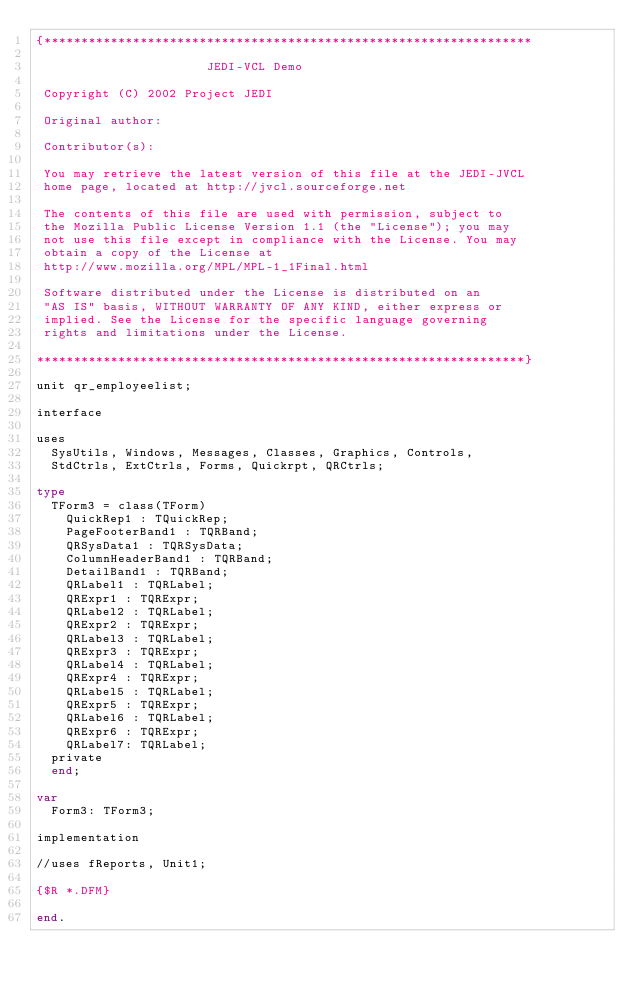Convert code to text. <code><loc_0><loc_0><loc_500><loc_500><_Pascal_>{******************************************************************

                       JEDI-VCL Demo

 Copyright (C) 2002 Project JEDI

 Original author:

 Contributor(s):

 You may retrieve the latest version of this file at the JEDI-JVCL
 home page, located at http://jvcl.sourceforge.net

 The contents of this file are used with permission, subject to
 the Mozilla Public License Version 1.1 (the "License"); you may
 not use this file except in compliance with the License. You may
 obtain a copy of the License at
 http://www.mozilla.org/MPL/MPL-1_1Final.html

 Software distributed under the License is distributed on an
 "AS IS" basis, WITHOUT WARRANTY OF ANY KIND, either express or
 implied. See the License for the specific language governing
 rights and limitations under the License.

******************************************************************}

unit qr_employeelist;

interface

uses
  SysUtils, Windows, Messages, Classes, Graphics, Controls,
  StdCtrls, ExtCtrls, Forms, Quickrpt, QRCtrls;

type
  TForm3 = class(TForm)
    QuickRep1 : TQuickRep;
    PageFooterBand1 : TQRBand;
    QRSysData1 : TQRSysData;
    ColumnHeaderBand1 : TQRBand;
    DetailBand1 : TQRBand;
    QRLabel1 : TQRLabel;
    QRExpr1 : TQRExpr;
    QRLabel2 : TQRLabel;
    QRExpr2 : TQRExpr;
    QRLabel3 : TQRLabel;
    QRExpr3 : TQRExpr;
    QRLabel4 : TQRLabel;
    QRExpr4 : TQRExpr;
    QRLabel5 : TQRLabel;
    QRExpr5 : TQRExpr;
    QRLabel6 : TQRLabel;
    QRExpr6 : TQRExpr;
    QRLabel7: TQRLabel;
  private
  end;

var
  Form3: TForm3;

implementation

//uses fReports, Unit1;

{$R *.DFM}

end.
</code> 